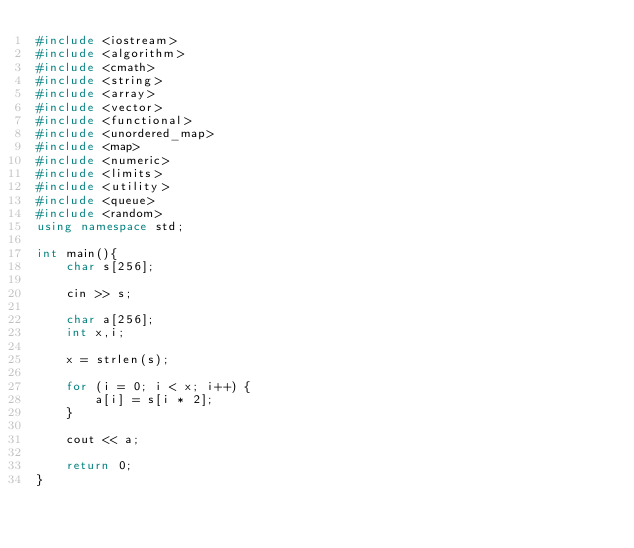<code> <loc_0><loc_0><loc_500><loc_500><_C++_>#include <iostream>
#include <algorithm>
#include <cmath>
#include <string>
#include <array>
#include <vector>
#include <functional>
#include <unordered_map>
#include <map>
#include <numeric>
#include <limits>
#include <utility>
#include <queue>
#include <random>
using namespace std;

int main(){
	char s[256];

	cin >> s;

	char a[256];
	int x,i;

	x = strlen(s);

	for (i = 0; i < x; i++) {
		a[i] = s[i * 2];
	}

	cout << a;

	return 0;
}</code> 